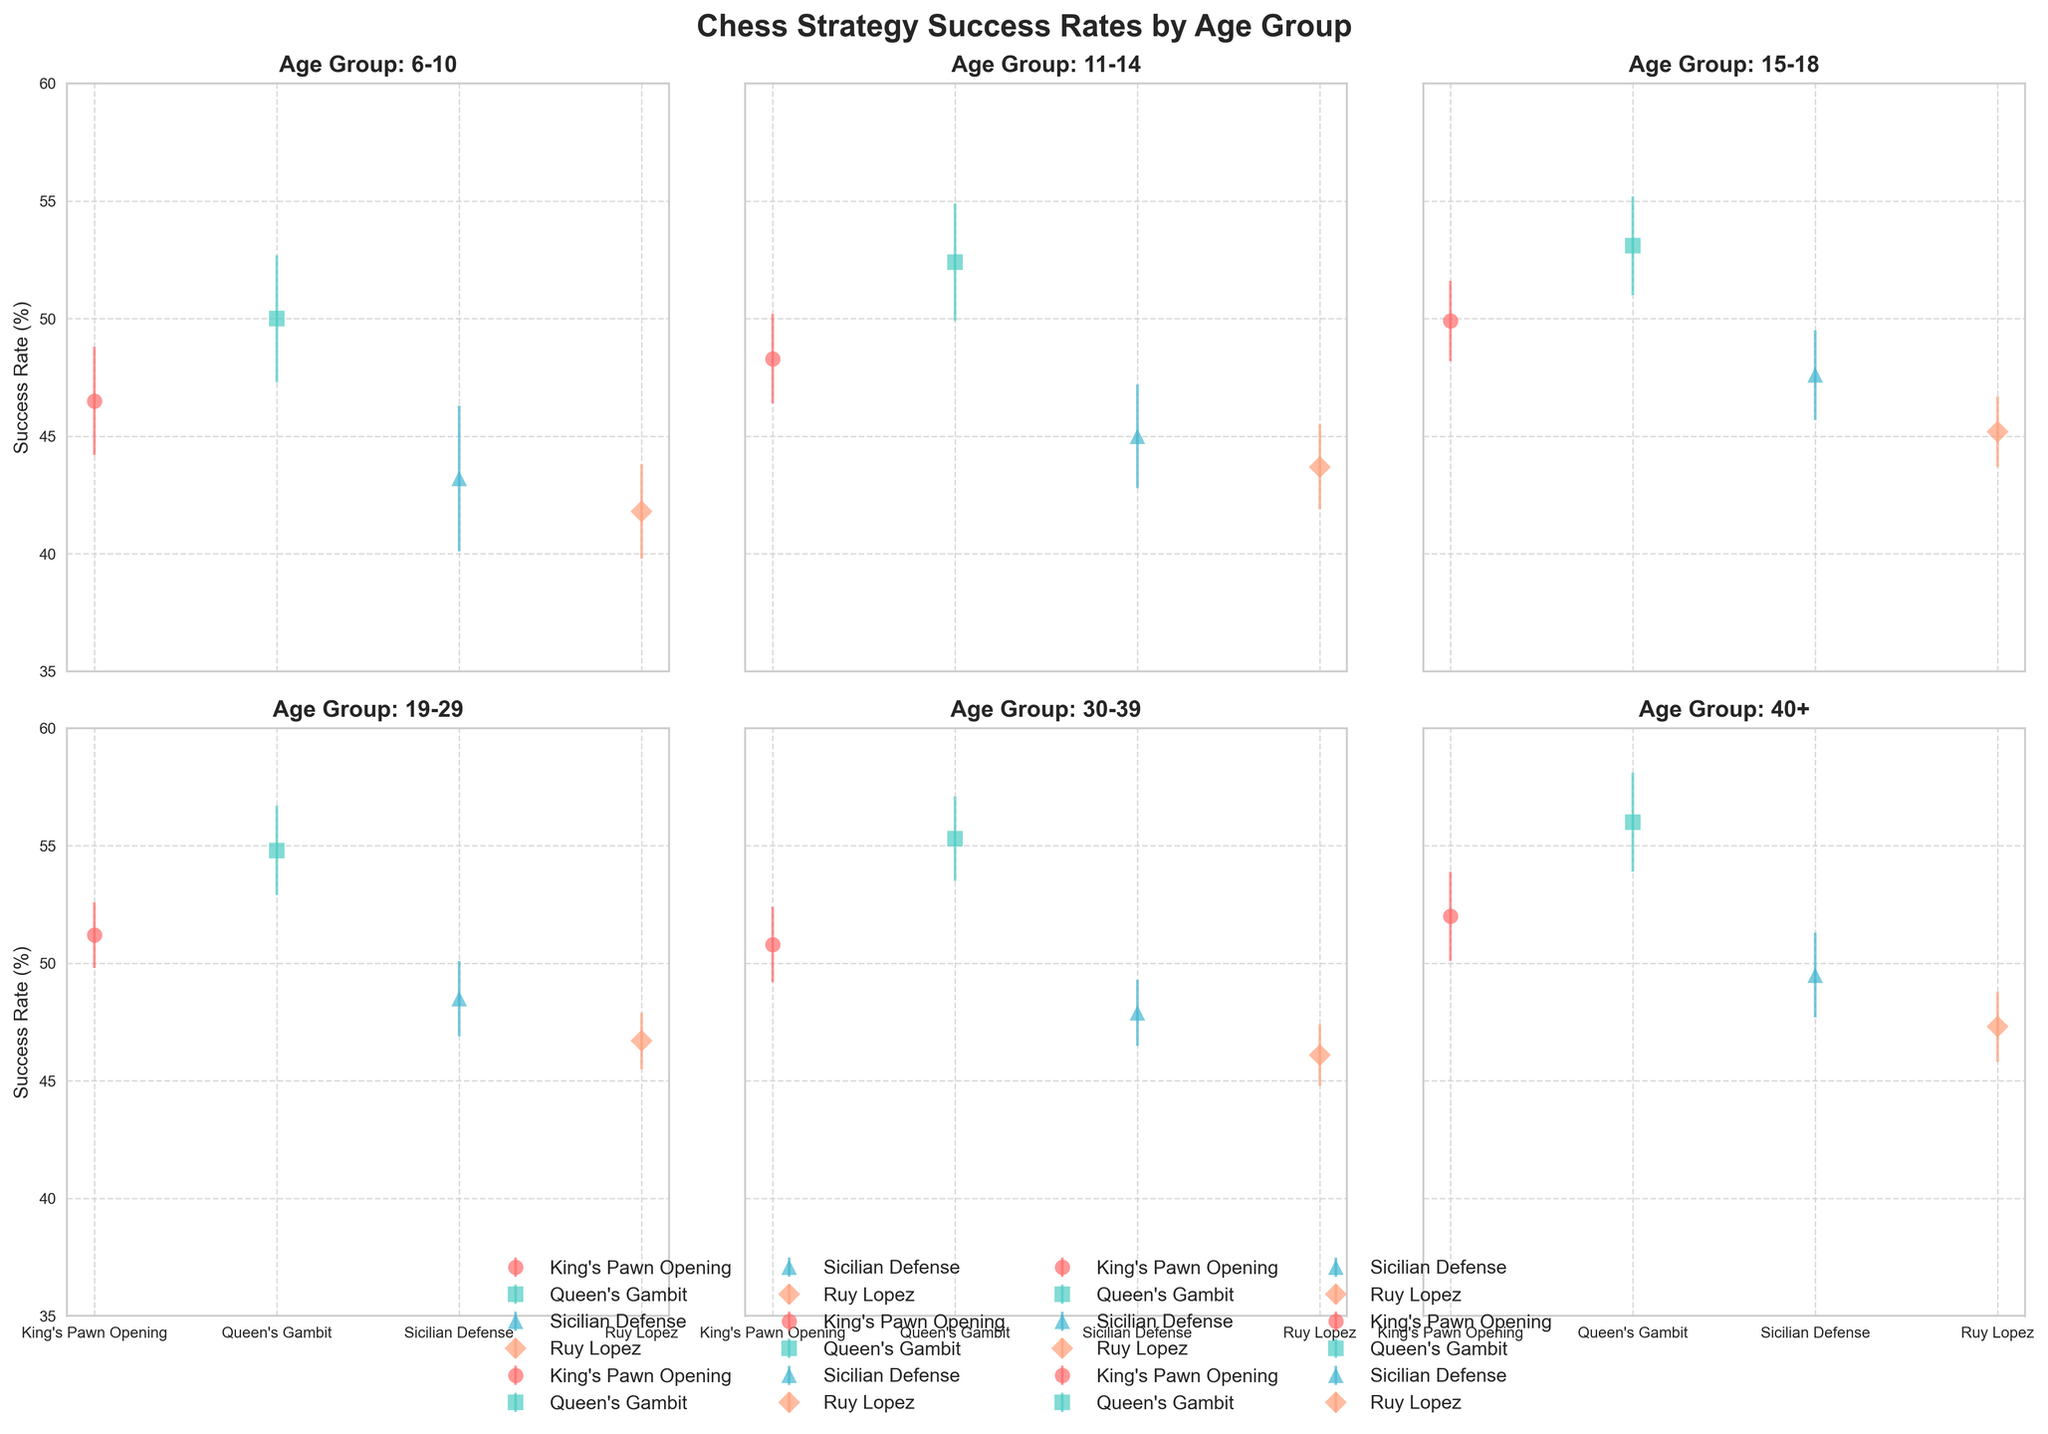Which age group sees the highest success rate for the Queen's Gambit strategy? The figure shows success rates for various strategies across different age groups. The highest success rate for the Queen's Gambit strategy can be found in the age group where this bar is the tallest.
Answer: 40+ Which strategy has the highest success rate in the 6-10 age group? Look at the subplot for the 6-10 age group and compare the height of the success rate bars for each strategy. The highest bar indicates the strategy with the highest success rate.
Answer: Queen's Gambit How does the success rate of the Sicilian Defense in the 11-14 age group compare to that in the 40+ age group? Compare the bars for Sicilian Defense in the subplots for 11-14 and 40+ age groups. Look at the difference in height to determine which one is higher.
Answer: Lower in 11-14 Across all age groups, which age group has the least variation (smallest error bars) in their success rates? Compare the length of the error bars across all subplots to determine which age group has the consistently shortest error bars.
Answer: 19-29 Which age group has the highest average success rate across all strategies? Calculate the average success rate for each age group by summing the rates of each strategy and dividing by the number of strategies, then compare these averages across age groups.
Answer: 40+ For the 15-18 age group, what is the difference in success rate between the Queen's Gambit and King's Pawn Opening strategies? Look at the subplot for the 15-18 age group and find the heights of the bars for the Queen's Gambit and King's Pawn Opening strategies, then subtract the lower value from the higher value.
Answer: 3.2 Which strategy has the smallest improvement in success rate as players age from 6-10 to 40+? For each strategy, subtract the success rate in the 6-10 age group from the success rate in the 40+ age group. The strategy with the smallest positive difference or closest to zero shows the smallest improvement.
Answer: Sicilian Defense What is the difference in the highest success rates between the youngest (6-10) and oldest (40+) age groups? Identify the highest success rate in both the 6-10 and 40+ age groups and subtract the 6-10 value from the 40+ value to find the difference.
Answer: 6 In which age group does the King's Pawn Opening strategy show the highest success rate? Look through all subplots to find the one where the King's Pawn Opening bar is the tallest.
Answer: 40+ 